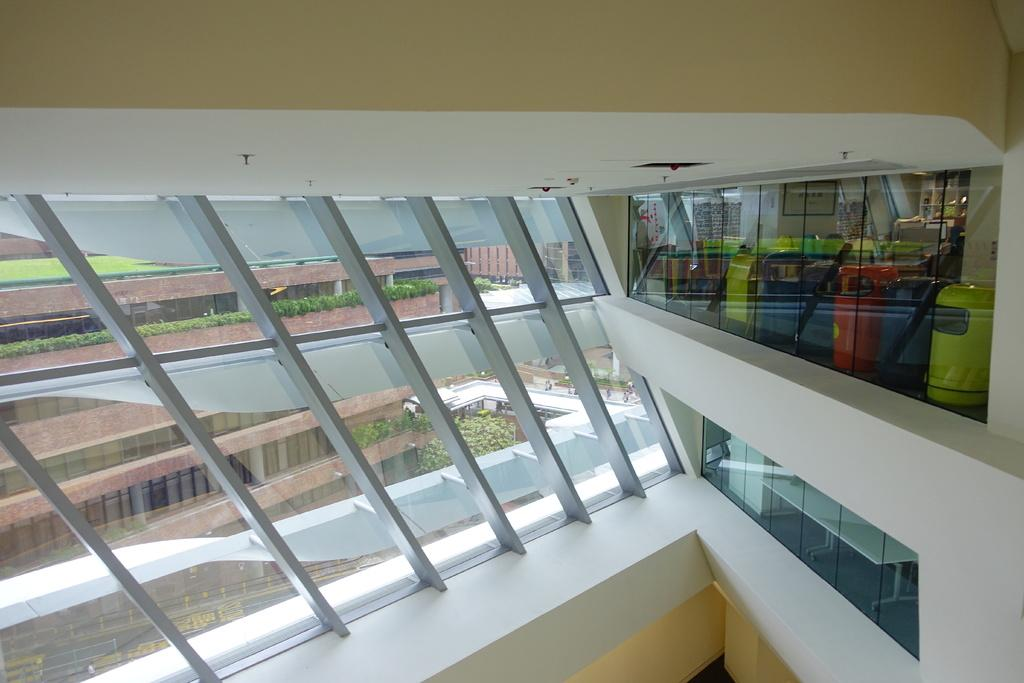What is the main feature in the middle of the image? There is a glass wall in the middle of the image. What can be seen through the glass wall? Trees and plants are visible through the glass wall, as well as a building. What is the structure at the top of the image? There is a wall at the top of the image. What type of fiction is being read by the apple in the image? There is no apple or any indication of reading in the image. 